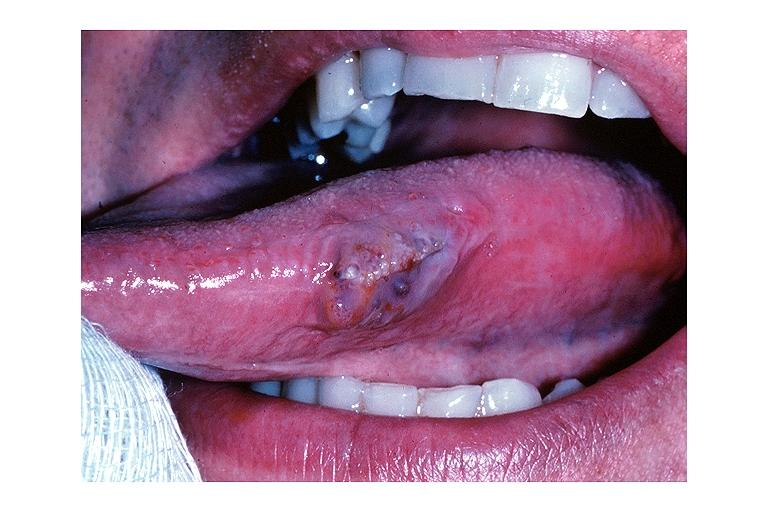does this image show lymphangioma?
Answer the question using a single word or phrase. Yes 